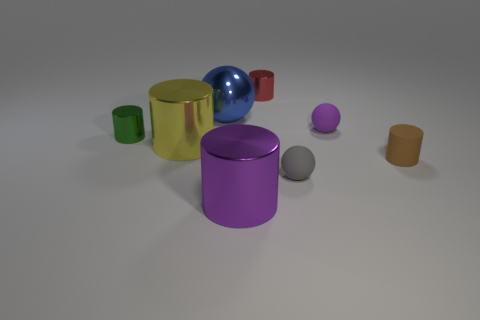Subtract all yellow cylinders. How many cylinders are left? 4 Subtract all purple cylinders. How many cylinders are left? 4 Subtract 1 cylinders. How many cylinders are left? 4 Subtract all cyan cylinders. Subtract all gray blocks. How many cylinders are left? 5 Add 1 tiny green cylinders. How many objects exist? 9 Subtract all spheres. How many objects are left? 5 Subtract all tiny brown matte cylinders. Subtract all small red cylinders. How many objects are left? 6 Add 6 yellow things. How many yellow things are left? 7 Add 3 tiny gray objects. How many tiny gray objects exist? 4 Subtract 0 green balls. How many objects are left? 8 